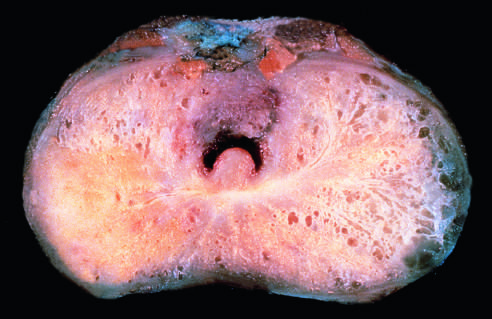what is seen on the posterior aspect (lower left)?
Answer the question using a single word or phrase. Carcinomatous tissue 